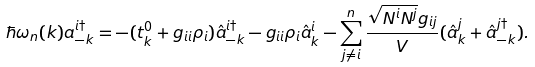<formula> <loc_0><loc_0><loc_500><loc_500>\hbar { \omega } _ { n } ( k ) a ^ { i \dag } _ { - k } = - ( t ^ { 0 } _ { k } + g _ { i i } \rho _ { i } ) \hat { a } ^ { i \dag } _ { - k } - g _ { i i } \rho _ { i } \hat { a } _ { k } ^ { i } - \sum ^ { n } _ { j \ne i } \frac { \sqrt { N ^ { i } N ^ { j } } g _ { i j } } { V } ( \hat { a } _ { k } ^ { j } + \hat { a } ^ { j \dag } _ { - k } ) .</formula> 